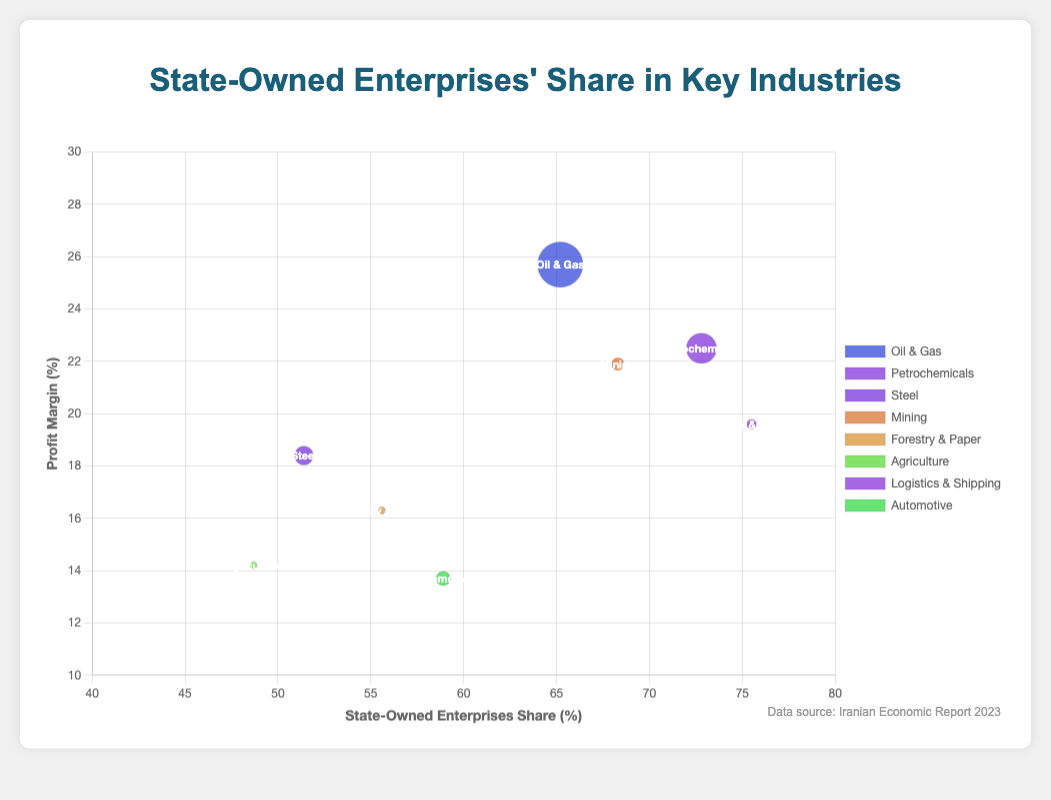How many different industries are displayed in the figure? The bubble chart contains multiple bubbles, each representing a different industry. By counting the data points and their corresponding labels, we see there are 8 different industries shown: Oil & Gas, Petrochemicals, Steel, Mining, Forestry & Paper, Agriculture, Logistics & Shipping, and Automotive.
Answer: 8 Which province's industry has the highest state-owned enterprise share? From the figure, identify the bubbles on the x-axis marked by the highest SOE share percentage. The bubble for Logistics & Shipping in Hormozgan has the highest SOE share at 75.5%.
Answer: Hormozgan What is the average profit margin of the industries in Tehran and Kerman? From the figure, note the profit margins marked on the y-axis for both Tehran (25.7%) and Kerman (21.9%). The average is calculated as (25.7 + 21.9) / 2.
Answer: 23.8% Which industry has the largest revenue among those displayed, and what is its revenue? Identify the size of the bubbles, as larger bubbles indicate higher revenue. The largest bubble corresponds to Oil & Gas in Tehran with revenue of $45.3 billion.
Answer: Oil & Gas, $45.3 billion Compare the profit margins of the Forestry & Paper industry in Mazandaran to the Agriculture industry in Fars. Which is higher? Analyze the y-axis values for both industries. The profit margin for Forestry & Paper in Mazandaran is 16.3%, and for Agriculture in Fars is 14.2%. Forestry & Paper is higher.
Answer: Forestry & Paper Which industry in East Azerbaijan has the smallest revenue bubble but the highest profit margin based on the chart? From the bubbles, assess the revenue size and profit margin for East Azerbaijan. The Automotive industry bubble is the only one present with a profit margin of 13.7% but a relatively smaller revenue bubble.
Answer: Automotive How does the profit margin of the Mining industry in Kerman compare to that of the Logistics & Shipping industry in Hormozgan? Check the y-axis values for both industries. Mining in Kerman has a profit margin of 21.9%, while Logistics & Shipping in Hormozgan has a profit margin of 19.6%. Mining in Kerman has a higher margin.
Answer: Mining What is the combined revenue of the Steel industry in Isfahan and the Petrochemicals industry in Khuzestan? Look at the bubble sizes and corresponding revenue values. Steel in Isfahan has $18.7 billion, and Petrochemicals in Khuzestan has $30.2 billion. The combined revenue is $18.7 billion + $30.2 billion = $48.9 billion.
Answer: $48.9 billion 